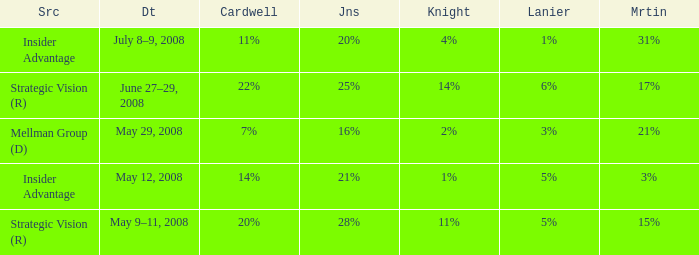What Lanier has a Cardwell of 20%? 5%. Give me the full table as a dictionary. {'header': ['Src', 'Dt', 'Cardwell', 'Jns', 'Knight', 'Lanier', 'Mrtin'], 'rows': [['Insider Advantage', 'July 8–9, 2008', '11%', '20%', '4%', '1%', '31%'], ['Strategic Vision (R)', 'June 27–29, 2008', '22%', '25%', '14%', '6%', '17%'], ['Mellman Group (D)', 'May 29, 2008', '7%', '16%', '2%', '3%', '21%'], ['Insider Advantage', 'May 12, 2008', '14%', '21%', '1%', '5%', '3%'], ['Strategic Vision (R)', 'May 9–11, 2008', '20%', '28%', '11%', '5%', '15%']]} 